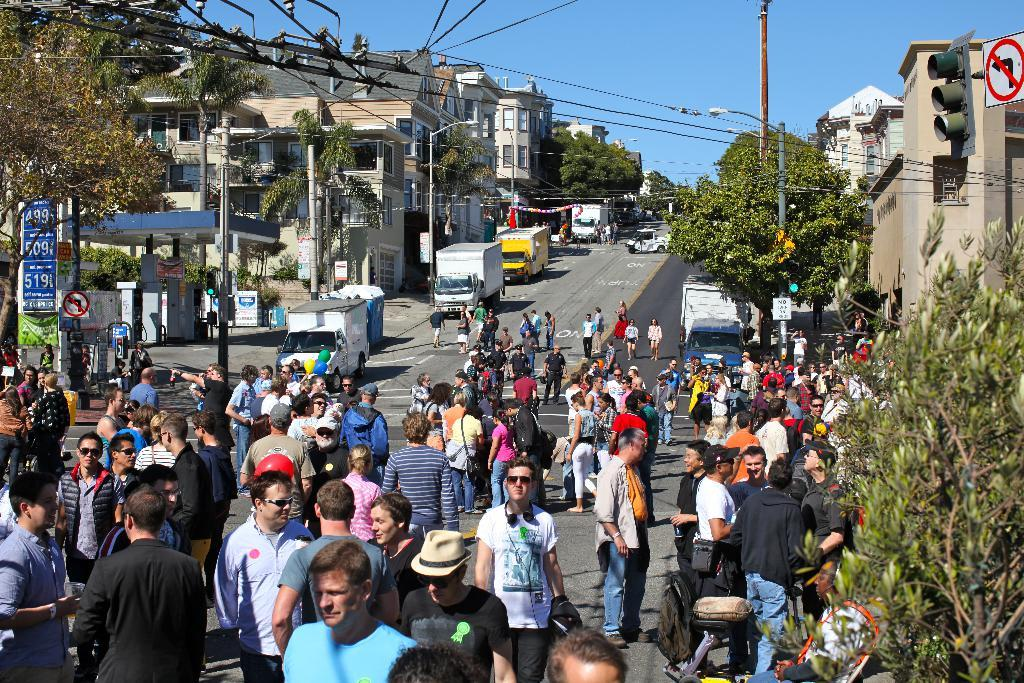What can be seen in the image that indicates a gathering of people? There is a crowd in the image. What is present on the road in the image? There are vehicles on the road in the image. What objects are present in the image that might be used for signage or advertisement? There are boards in the image. What type of structures can be seen in the image? There are buildings in the image. What is visible in the background of the image? The sky is visible in the background of the image. What type of pets can be seen in the image? There are no pets visible in the image. What is the time of day depicted in the image? The time of day cannot be determined from the image, as there is no specific information about lighting or shadows. 